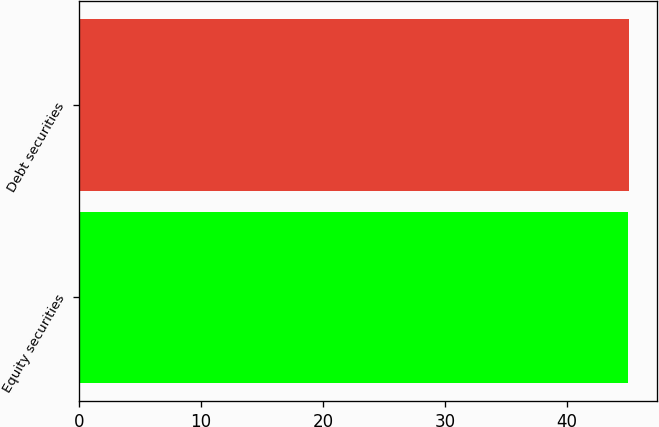Convert chart. <chart><loc_0><loc_0><loc_500><loc_500><bar_chart><fcel>Equity securities<fcel>Debt securities<nl><fcel>45<fcel>45.1<nl></chart> 